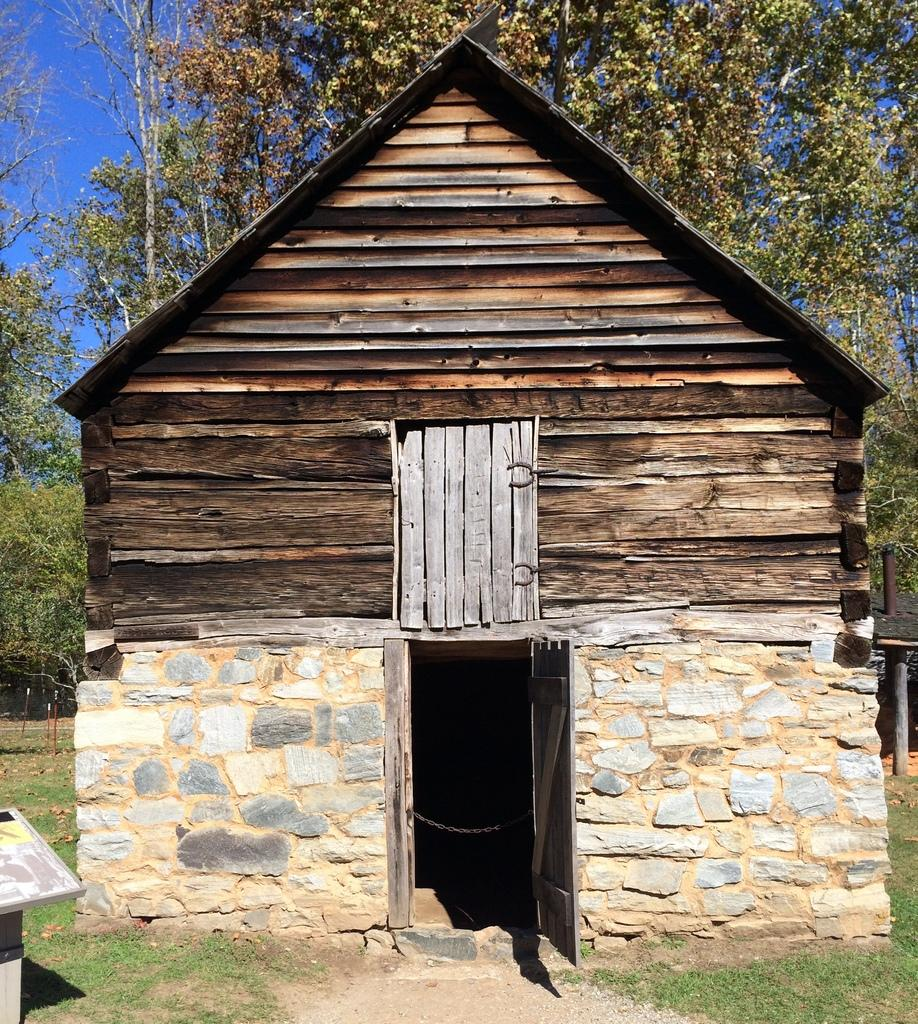What type of structure is in the image? There is a house in the image. What material is used for the roof of the house? The house has a wooden roof. What material is used for the walls of the house? The house has a stone wall. What type of vegetation can be seen in the background of the image? There are trees in the background of the image. What type of ground is visible in the image? There is grass visible on the ground. What part of the natural environment is visible in the image? The sky is visible in the image. Can you see any bees flying around the sand in the image? There is no sand or bees present in the image. 